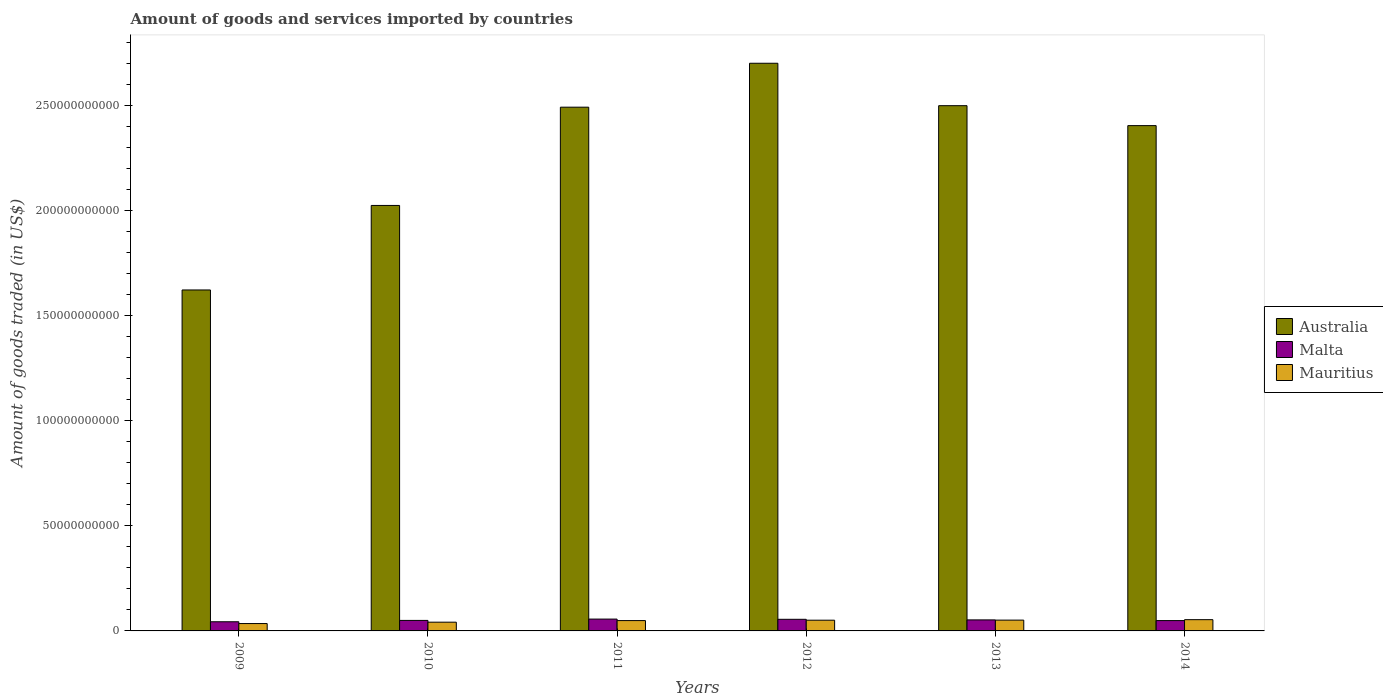How many groups of bars are there?
Make the answer very short. 6. Are the number of bars per tick equal to the number of legend labels?
Give a very brief answer. Yes. Are the number of bars on each tick of the X-axis equal?
Provide a succinct answer. Yes. How many bars are there on the 2nd tick from the left?
Ensure brevity in your answer.  3. What is the label of the 3rd group of bars from the left?
Provide a succinct answer. 2011. What is the total amount of goods and services imported in Malta in 2013?
Ensure brevity in your answer.  5.25e+09. Across all years, what is the maximum total amount of goods and services imported in Malta?
Provide a succinct answer. 5.64e+09. Across all years, what is the minimum total amount of goods and services imported in Mauritius?
Ensure brevity in your answer.  3.50e+09. In which year was the total amount of goods and services imported in Malta maximum?
Give a very brief answer. 2011. What is the total total amount of goods and services imported in Australia in the graph?
Ensure brevity in your answer.  1.37e+12. What is the difference between the total amount of goods and services imported in Mauritius in 2009 and that in 2013?
Offer a very short reply. -1.64e+09. What is the difference between the total amount of goods and services imported in Australia in 2011 and the total amount of goods and services imported in Malta in 2009?
Give a very brief answer. 2.45e+11. What is the average total amount of goods and services imported in Malta per year?
Your response must be concise. 5.12e+09. In the year 2014, what is the difference between the total amount of goods and services imported in Mauritius and total amount of goods and services imported in Malta?
Make the answer very short. 4.33e+08. In how many years, is the total amount of goods and services imported in Australia greater than 80000000000 US$?
Your response must be concise. 6. What is the ratio of the total amount of goods and services imported in Mauritius in 2009 to that in 2014?
Ensure brevity in your answer.  0.65. What is the difference between the highest and the second highest total amount of goods and services imported in Australia?
Keep it short and to the point. 2.02e+1. What is the difference between the highest and the lowest total amount of goods and services imported in Australia?
Give a very brief answer. 1.08e+11. In how many years, is the total amount of goods and services imported in Australia greater than the average total amount of goods and services imported in Australia taken over all years?
Offer a very short reply. 4. What does the 1st bar from the left in 2014 represents?
Your answer should be very brief. Australia. What does the 1st bar from the right in 2009 represents?
Your response must be concise. Mauritius. Is it the case that in every year, the sum of the total amount of goods and services imported in Malta and total amount of goods and services imported in Mauritius is greater than the total amount of goods and services imported in Australia?
Give a very brief answer. No. What is the difference between two consecutive major ticks on the Y-axis?
Your response must be concise. 5.00e+1. Does the graph contain grids?
Make the answer very short. No. Where does the legend appear in the graph?
Give a very brief answer. Center right. How many legend labels are there?
Your answer should be compact. 3. What is the title of the graph?
Offer a terse response. Amount of goods and services imported by countries. What is the label or title of the Y-axis?
Offer a terse response. Amount of goods traded (in US$). What is the Amount of goods traded (in US$) in Australia in 2009?
Keep it short and to the point. 1.62e+11. What is the Amount of goods traded (in US$) of Malta in 2009?
Provide a succinct answer. 4.36e+09. What is the Amount of goods traded (in US$) in Mauritius in 2009?
Provide a short and direct response. 3.50e+09. What is the Amount of goods traded (in US$) in Australia in 2010?
Ensure brevity in your answer.  2.02e+11. What is the Amount of goods traded (in US$) in Malta in 2010?
Offer a very short reply. 5.00e+09. What is the Amount of goods traded (in US$) in Mauritius in 2010?
Offer a very short reply. 4.16e+09. What is the Amount of goods traded (in US$) of Australia in 2011?
Your response must be concise. 2.49e+11. What is the Amount of goods traded (in US$) of Malta in 2011?
Provide a succinct answer. 5.64e+09. What is the Amount of goods traded (in US$) in Mauritius in 2011?
Offer a very short reply. 4.92e+09. What is the Amount of goods traded (in US$) in Australia in 2012?
Ensure brevity in your answer.  2.70e+11. What is the Amount of goods traded (in US$) of Malta in 2012?
Give a very brief answer. 5.53e+09. What is the Amount of goods traded (in US$) in Mauritius in 2012?
Make the answer very short. 5.10e+09. What is the Amount of goods traded (in US$) in Australia in 2013?
Keep it short and to the point. 2.50e+11. What is the Amount of goods traded (in US$) in Malta in 2013?
Your answer should be compact. 5.25e+09. What is the Amount of goods traded (in US$) of Mauritius in 2013?
Provide a succinct answer. 5.14e+09. What is the Amount of goods traded (in US$) of Australia in 2014?
Provide a short and direct response. 2.40e+11. What is the Amount of goods traded (in US$) of Malta in 2014?
Your response must be concise. 4.92e+09. What is the Amount of goods traded (in US$) of Mauritius in 2014?
Ensure brevity in your answer.  5.35e+09. Across all years, what is the maximum Amount of goods traded (in US$) of Australia?
Your answer should be very brief. 2.70e+11. Across all years, what is the maximum Amount of goods traded (in US$) in Malta?
Provide a succinct answer. 5.64e+09. Across all years, what is the maximum Amount of goods traded (in US$) in Mauritius?
Provide a short and direct response. 5.35e+09. Across all years, what is the minimum Amount of goods traded (in US$) in Australia?
Your answer should be very brief. 1.62e+11. Across all years, what is the minimum Amount of goods traded (in US$) of Malta?
Provide a succinct answer. 4.36e+09. Across all years, what is the minimum Amount of goods traded (in US$) in Mauritius?
Keep it short and to the point. 3.50e+09. What is the total Amount of goods traded (in US$) in Australia in the graph?
Ensure brevity in your answer.  1.37e+12. What is the total Amount of goods traded (in US$) in Malta in the graph?
Make the answer very short. 3.07e+1. What is the total Amount of goods traded (in US$) of Mauritius in the graph?
Give a very brief answer. 2.82e+1. What is the difference between the Amount of goods traded (in US$) of Australia in 2009 and that in 2010?
Provide a short and direct response. -4.02e+1. What is the difference between the Amount of goods traded (in US$) of Malta in 2009 and that in 2010?
Make the answer very short. -6.45e+08. What is the difference between the Amount of goods traded (in US$) in Mauritius in 2009 and that in 2010?
Your answer should be compact. -6.53e+08. What is the difference between the Amount of goods traded (in US$) in Australia in 2009 and that in 2011?
Keep it short and to the point. -8.70e+1. What is the difference between the Amount of goods traded (in US$) of Malta in 2009 and that in 2011?
Offer a terse response. -1.28e+09. What is the difference between the Amount of goods traded (in US$) of Mauritius in 2009 and that in 2011?
Keep it short and to the point. -1.41e+09. What is the difference between the Amount of goods traded (in US$) in Australia in 2009 and that in 2012?
Give a very brief answer. -1.08e+11. What is the difference between the Amount of goods traded (in US$) of Malta in 2009 and that in 2012?
Ensure brevity in your answer.  -1.17e+09. What is the difference between the Amount of goods traded (in US$) in Mauritius in 2009 and that in 2012?
Give a very brief answer. -1.60e+09. What is the difference between the Amount of goods traded (in US$) in Australia in 2009 and that in 2013?
Make the answer very short. -8.77e+1. What is the difference between the Amount of goods traded (in US$) in Malta in 2009 and that in 2013?
Your response must be concise. -8.90e+08. What is the difference between the Amount of goods traded (in US$) of Mauritius in 2009 and that in 2013?
Provide a short and direct response. -1.64e+09. What is the difference between the Amount of goods traded (in US$) of Australia in 2009 and that in 2014?
Your response must be concise. -7.82e+1. What is the difference between the Amount of goods traded (in US$) of Malta in 2009 and that in 2014?
Give a very brief answer. -5.63e+08. What is the difference between the Amount of goods traded (in US$) of Mauritius in 2009 and that in 2014?
Your answer should be compact. -1.85e+09. What is the difference between the Amount of goods traded (in US$) in Australia in 2010 and that in 2011?
Your answer should be very brief. -4.68e+1. What is the difference between the Amount of goods traded (in US$) of Malta in 2010 and that in 2011?
Make the answer very short. -6.33e+08. What is the difference between the Amount of goods traded (in US$) in Mauritius in 2010 and that in 2011?
Ensure brevity in your answer.  -7.61e+08. What is the difference between the Amount of goods traded (in US$) in Australia in 2010 and that in 2012?
Your response must be concise. -6.77e+1. What is the difference between the Amount of goods traded (in US$) in Malta in 2010 and that in 2012?
Provide a short and direct response. -5.25e+08. What is the difference between the Amount of goods traded (in US$) in Mauritius in 2010 and that in 2012?
Offer a very short reply. -9.48e+08. What is the difference between the Amount of goods traded (in US$) of Australia in 2010 and that in 2013?
Your response must be concise. -4.75e+1. What is the difference between the Amount of goods traded (in US$) of Malta in 2010 and that in 2013?
Keep it short and to the point. -2.46e+08. What is the difference between the Amount of goods traded (in US$) of Mauritius in 2010 and that in 2013?
Your answer should be very brief. -9.82e+08. What is the difference between the Amount of goods traded (in US$) of Australia in 2010 and that in 2014?
Offer a terse response. -3.80e+1. What is the difference between the Amount of goods traded (in US$) of Malta in 2010 and that in 2014?
Make the answer very short. 8.20e+07. What is the difference between the Amount of goods traded (in US$) of Mauritius in 2010 and that in 2014?
Keep it short and to the point. -1.20e+09. What is the difference between the Amount of goods traded (in US$) in Australia in 2011 and that in 2012?
Provide a short and direct response. -2.09e+1. What is the difference between the Amount of goods traded (in US$) of Malta in 2011 and that in 2012?
Give a very brief answer. 1.08e+08. What is the difference between the Amount of goods traded (in US$) in Mauritius in 2011 and that in 2012?
Your answer should be very brief. -1.87e+08. What is the difference between the Amount of goods traded (in US$) in Australia in 2011 and that in 2013?
Offer a very short reply. -7.10e+08. What is the difference between the Amount of goods traded (in US$) in Malta in 2011 and that in 2013?
Offer a very short reply. 3.87e+08. What is the difference between the Amount of goods traded (in US$) of Mauritius in 2011 and that in 2013?
Provide a succinct answer. -2.22e+08. What is the difference between the Amount of goods traded (in US$) of Australia in 2011 and that in 2014?
Provide a short and direct response. 8.77e+09. What is the difference between the Amount of goods traded (in US$) of Malta in 2011 and that in 2014?
Give a very brief answer. 7.15e+08. What is the difference between the Amount of goods traded (in US$) in Mauritius in 2011 and that in 2014?
Offer a terse response. -4.36e+08. What is the difference between the Amount of goods traded (in US$) of Australia in 2012 and that in 2013?
Ensure brevity in your answer.  2.02e+1. What is the difference between the Amount of goods traded (in US$) of Malta in 2012 and that in 2013?
Make the answer very short. 2.79e+08. What is the difference between the Amount of goods traded (in US$) of Mauritius in 2012 and that in 2013?
Offer a terse response. -3.42e+07. What is the difference between the Amount of goods traded (in US$) of Australia in 2012 and that in 2014?
Your answer should be very brief. 2.97e+1. What is the difference between the Amount of goods traded (in US$) in Malta in 2012 and that in 2014?
Provide a succinct answer. 6.07e+08. What is the difference between the Amount of goods traded (in US$) in Mauritius in 2012 and that in 2014?
Give a very brief answer. -2.49e+08. What is the difference between the Amount of goods traded (in US$) in Australia in 2013 and that in 2014?
Your answer should be very brief. 9.48e+09. What is the difference between the Amount of goods traded (in US$) in Malta in 2013 and that in 2014?
Ensure brevity in your answer.  3.28e+08. What is the difference between the Amount of goods traded (in US$) of Mauritius in 2013 and that in 2014?
Ensure brevity in your answer.  -2.14e+08. What is the difference between the Amount of goods traded (in US$) in Australia in 2009 and the Amount of goods traded (in US$) in Malta in 2010?
Ensure brevity in your answer.  1.57e+11. What is the difference between the Amount of goods traded (in US$) of Australia in 2009 and the Amount of goods traded (in US$) of Mauritius in 2010?
Keep it short and to the point. 1.58e+11. What is the difference between the Amount of goods traded (in US$) in Malta in 2009 and the Amount of goods traded (in US$) in Mauritius in 2010?
Provide a succinct answer. 2.01e+08. What is the difference between the Amount of goods traded (in US$) of Australia in 2009 and the Amount of goods traded (in US$) of Malta in 2011?
Ensure brevity in your answer.  1.57e+11. What is the difference between the Amount of goods traded (in US$) of Australia in 2009 and the Amount of goods traded (in US$) of Mauritius in 2011?
Your answer should be compact. 1.57e+11. What is the difference between the Amount of goods traded (in US$) of Malta in 2009 and the Amount of goods traded (in US$) of Mauritius in 2011?
Your answer should be very brief. -5.60e+08. What is the difference between the Amount of goods traded (in US$) in Australia in 2009 and the Amount of goods traded (in US$) in Malta in 2012?
Your response must be concise. 1.57e+11. What is the difference between the Amount of goods traded (in US$) of Australia in 2009 and the Amount of goods traded (in US$) of Mauritius in 2012?
Give a very brief answer. 1.57e+11. What is the difference between the Amount of goods traded (in US$) of Malta in 2009 and the Amount of goods traded (in US$) of Mauritius in 2012?
Provide a succinct answer. -7.47e+08. What is the difference between the Amount of goods traded (in US$) of Australia in 2009 and the Amount of goods traded (in US$) of Malta in 2013?
Your answer should be very brief. 1.57e+11. What is the difference between the Amount of goods traded (in US$) in Australia in 2009 and the Amount of goods traded (in US$) in Mauritius in 2013?
Your answer should be very brief. 1.57e+11. What is the difference between the Amount of goods traded (in US$) in Malta in 2009 and the Amount of goods traded (in US$) in Mauritius in 2013?
Offer a terse response. -7.81e+08. What is the difference between the Amount of goods traded (in US$) of Australia in 2009 and the Amount of goods traded (in US$) of Malta in 2014?
Keep it short and to the point. 1.57e+11. What is the difference between the Amount of goods traded (in US$) of Australia in 2009 and the Amount of goods traded (in US$) of Mauritius in 2014?
Offer a terse response. 1.57e+11. What is the difference between the Amount of goods traded (in US$) in Malta in 2009 and the Amount of goods traded (in US$) in Mauritius in 2014?
Your response must be concise. -9.96e+08. What is the difference between the Amount of goods traded (in US$) in Australia in 2010 and the Amount of goods traded (in US$) in Malta in 2011?
Provide a short and direct response. 1.97e+11. What is the difference between the Amount of goods traded (in US$) in Australia in 2010 and the Amount of goods traded (in US$) in Mauritius in 2011?
Provide a succinct answer. 1.98e+11. What is the difference between the Amount of goods traded (in US$) in Malta in 2010 and the Amount of goods traded (in US$) in Mauritius in 2011?
Give a very brief answer. 8.51e+07. What is the difference between the Amount of goods traded (in US$) in Australia in 2010 and the Amount of goods traded (in US$) in Malta in 2012?
Provide a succinct answer. 1.97e+11. What is the difference between the Amount of goods traded (in US$) in Australia in 2010 and the Amount of goods traded (in US$) in Mauritius in 2012?
Provide a short and direct response. 1.97e+11. What is the difference between the Amount of goods traded (in US$) in Malta in 2010 and the Amount of goods traded (in US$) in Mauritius in 2012?
Offer a very short reply. -1.02e+08. What is the difference between the Amount of goods traded (in US$) in Australia in 2010 and the Amount of goods traded (in US$) in Malta in 2013?
Keep it short and to the point. 1.97e+11. What is the difference between the Amount of goods traded (in US$) of Australia in 2010 and the Amount of goods traded (in US$) of Mauritius in 2013?
Keep it short and to the point. 1.97e+11. What is the difference between the Amount of goods traded (in US$) of Malta in 2010 and the Amount of goods traded (in US$) of Mauritius in 2013?
Make the answer very short. -1.37e+08. What is the difference between the Amount of goods traded (in US$) in Australia in 2010 and the Amount of goods traded (in US$) in Malta in 2014?
Your answer should be very brief. 1.98e+11. What is the difference between the Amount of goods traded (in US$) in Australia in 2010 and the Amount of goods traded (in US$) in Mauritius in 2014?
Offer a very short reply. 1.97e+11. What is the difference between the Amount of goods traded (in US$) in Malta in 2010 and the Amount of goods traded (in US$) in Mauritius in 2014?
Provide a succinct answer. -3.51e+08. What is the difference between the Amount of goods traded (in US$) in Australia in 2011 and the Amount of goods traded (in US$) in Malta in 2012?
Your answer should be very brief. 2.44e+11. What is the difference between the Amount of goods traded (in US$) in Australia in 2011 and the Amount of goods traded (in US$) in Mauritius in 2012?
Provide a succinct answer. 2.44e+11. What is the difference between the Amount of goods traded (in US$) in Malta in 2011 and the Amount of goods traded (in US$) in Mauritius in 2012?
Keep it short and to the point. 5.31e+08. What is the difference between the Amount of goods traded (in US$) in Australia in 2011 and the Amount of goods traded (in US$) in Malta in 2013?
Keep it short and to the point. 2.44e+11. What is the difference between the Amount of goods traded (in US$) of Australia in 2011 and the Amount of goods traded (in US$) of Mauritius in 2013?
Your answer should be very brief. 2.44e+11. What is the difference between the Amount of goods traded (in US$) of Malta in 2011 and the Amount of goods traded (in US$) of Mauritius in 2013?
Your answer should be compact. 4.96e+08. What is the difference between the Amount of goods traded (in US$) in Australia in 2011 and the Amount of goods traded (in US$) in Malta in 2014?
Your response must be concise. 2.44e+11. What is the difference between the Amount of goods traded (in US$) of Australia in 2011 and the Amount of goods traded (in US$) of Mauritius in 2014?
Your response must be concise. 2.44e+11. What is the difference between the Amount of goods traded (in US$) in Malta in 2011 and the Amount of goods traded (in US$) in Mauritius in 2014?
Your response must be concise. 2.82e+08. What is the difference between the Amount of goods traded (in US$) in Australia in 2012 and the Amount of goods traded (in US$) in Malta in 2013?
Your answer should be very brief. 2.65e+11. What is the difference between the Amount of goods traded (in US$) in Australia in 2012 and the Amount of goods traded (in US$) in Mauritius in 2013?
Keep it short and to the point. 2.65e+11. What is the difference between the Amount of goods traded (in US$) of Malta in 2012 and the Amount of goods traded (in US$) of Mauritius in 2013?
Offer a terse response. 3.88e+08. What is the difference between the Amount of goods traded (in US$) in Australia in 2012 and the Amount of goods traded (in US$) in Malta in 2014?
Offer a very short reply. 2.65e+11. What is the difference between the Amount of goods traded (in US$) in Australia in 2012 and the Amount of goods traded (in US$) in Mauritius in 2014?
Your answer should be very brief. 2.65e+11. What is the difference between the Amount of goods traded (in US$) in Malta in 2012 and the Amount of goods traded (in US$) in Mauritius in 2014?
Your response must be concise. 1.74e+08. What is the difference between the Amount of goods traded (in US$) of Australia in 2013 and the Amount of goods traded (in US$) of Malta in 2014?
Offer a terse response. 2.45e+11. What is the difference between the Amount of goods traded (in US$) in Australia in 2013 and the Amount of goods traded (in US$) in Mauritius in 2014?
Give a very brief answer. 2.45e+11. What is the difference between the Amount of goods traded (in US$) of Malta in 2013 and the Amount of goods traded (in US$) of Mauritius in 2014?
Ensure brevity in your answer.  -1.05e+08. What is the average Amount of goods traded (in US$) of Australia per year?
Your answer should be compact. 2.29e+11. What is the average Amount of goods traded (in US$) in Malta per year?
Provide a succinct answer. 5.12e+09. What is the average Amount of goods traded (in US$) in Mauritius per year?
Your response must be concise. 4.70e+09. In the year 2009, what is the difference between the Amount of goods traded (in US$) of Australia and Amount of goods traded (in US$) of Malta?
Your answer should be compact. 1.58e+11. In the year 2009, what is the difference between the Amount of goods traded (in US$) in Australia and Amount of goods traded (in US$) in Mauritius?
Ensure brevity in your answer.  1.59e+11. In the year 2009, what is the difference between the Amount of goods traded (in US$) in Malta and Amount of goods traded (in US$) in Mauritius?
Your answer should be very brief. 8.54e+08. In the year 2010, what is the difference between the Amount of goods traded (in US$) of Australia and Amount of goods traded (in US$) of Malta?
Provide a short and direct response. 1.97e+11. In the year 2010, what is the difference between the Amount of goods traded (in US$) in Australia and Amount of goods traded (in US$) in Mauritius?
Offer a terse response. 1.98e+11. In the year 2010, what is the difference between the Amount of goods traded (in US$) in Malta and Amount of goods traded (in US$) in Mauritius?
Offer a very short reply. 8.46e+08. In the year 2011, what is the difference between the Amount of goods traded (in US$) in Australia and Amount of goods traded (in US$) in Malta?
Offer a terse response. 2.44e+11. In the year 2011, what is the difference between the Amount of goods traded (in US$) in Australia and Amount of goods traded (in US$) in Mauritius?
Give a very brief answer. 2.44e+11. In the year 2011, what is the difference between the Amount of goods traded (in US$) of Malta and Amount of goods traded (in US$) of Mauritius?
Your answer should be very brief. 7.18e+08. In the year 2012, what is the difference between the Amount of goods traded (in US$) in Australia and Amount of goods traded (in US$) in Malta?
Keep it short and to the point. 2.65e+11. In the year 2012, what is the difference between the Amount of goods traded (in US$) in Australia and Amount of goods traded (in US$) in Mauritius?
Your answer should be compact. 2.65e+11. In the year 2012, what is the difference between the Amount of goods traded (in US$) of Malta and Amount of goods traded (in US$) of Mauritius?
Give a very brief answer. 4.23e+08. In the year 2013, what is the difference between the Amount of goods traded (in US$) of Australia and Amount of goods traded (in US$) of Malta?
Make the answer very short. 2.45e+11. In the year 2013, what is the difference between the Amount of goods traded (in US$) in Australia and Amount of goods traded (in US$) in Mauritius?
Keep it short and to the point. 2.45e+11. In the year 2013, what is the difference between the Amount of goods traded (in US$) of Malta and Amount of goods traded (in US$) of Mauritius?
Keep it short and to the point. 1.09e+08. In the year 2014, what is the difference between the Amount of goods traded (in US$) of Australia and Amount of goods traded (in US$) of Malta?
Provide a short and direct response. 2.36e+11. In the year 2014, what is the difference between the Amount of goods traded (in US$) in Australia and Amount of goods traded (in US$) in Mauritius?
Make the answer very short. 2.35e+11. In the year 2014, what is the difference between the Amount of goods traded (in US$) in Malta and Amount of goods traded (in US$) in Mauritius?
Your answer should be very brief. -4.33e+08. What is the ratio of the Amount of goods traded (in US$) in Australia in 2009 to that in 2010?
Ensure brevity in your answer.  0.8. What is the ratio of the Amount of goods traded (in US$) in Malta in 2009 to that in 2010?
Offer a terse response. 0.87. What is the ratio of the Amount of goods traded (in US$) in Mauritius in 2009 to that in 2010?
Make the answer very short. 0.84. What is the ratio of the Amount of goods traded (in US$) in Australia in 2009 to that in 2011?
Keep it short and to the point. 0.65. What is the ratio of the Amount of goods traded (in US$) in Malta in 2009 to that in 2011?
Offer a terse response. 0.77. What is the ratio of the Amount of goods traded (in US$) in Mauritius in 2009 to that in 2011?
Your response must be concise. 0.71. What is the ratio of the Amount of goods traded (in US$) of Australia in 2009 to that in 2012?
Your response must be concise. 0.6. What is the ratio of the Amount of goods traded (in US$) in Malta in 2009 to that in 2012?
Provide a succinct answer. 0.79. What is the ratio of the Amount of goods traded (in US$) of Mauritius in 2009 to that in 2012?
Your response must be concise. 0.69. What is the ratio of the Amount of goods traded (in US$) of Australia in 2009 to that in 2013?
Make the answer very short. 0.65. What is the ratio of the Amount of goods traded (in US$) of Malta in 2009 to that in 2013?
Keep it short and to the point. 0.83. What is the ratio of the Amount of goods traded (in US$) of Mauritius in 2009 to that in 2013?
Provide a succinct answer. 0.68. What is the ratio of the Amount of goods traded (in US$) of Australia in 2009 to that in 2014?
Give a very brief answer. 0.67. What is the ratio of the Amount of goods traded (in US$) of Malta in 2009 to that in 2014?
Your answer should be compact. 0.89. What is the ratio of the Amount of goods traded (in US$) of Mauritius in 2009 to that in 2014?
Your answer should be compact. 0.65. What is the ratio of the Amount of goods traded (in US$) of Australia in 2010 to that in 2011?
Offer a very short reply. 0.81. What is the ratio of the Amount of goods traded (in US$) in Malta in 2010 to that in 2011?
Your answer should be very brief. 0.89. What is the ratio of the Amount of goods traded (in US$) of Mauritius in 2010 to that in 2011?
Provide a succinct answer. 0.85. What is the ratio of the Amount of goods traded (in US$) in Australia in 2010 to that in 2012?
Provide a short and direct response. 0.75. What is the ratio of the Amount of goods traded (in US$) in Malta in 2010 to that in 2012?
Ensure brevity in your answer.  0.91. What is the ratio of the Amount of goods traded (in US$) in Mauritius in 2010 to that in 2012?
Give a very brief answer. 0.81. What is the ratio of the Amount of goods traded (in US$) of Australia in 2010 to that in 2013?
Provide a short and direct response. 0.81. What is the ratio of the Amount of goods traded (in US$) in Malta in 2010 to that in 2013?
Ensure brevity in your answer.  0.95. What is the ratio of the Amount of goods traded (in US$) in Mauritius in 2010 to that in 2013?
Provide a short and direct response. 0.81. What is the ratio of the Amount of goods traded (in US$) in Australia in 2010 to that in 2014?
Make the answer very short. 0.84. What is the ratio of the Amount of goods traded (in US$) in Malta in 2010 to that in 2014?
Offer a very short reply. 1.02. What is the ratio of the Amount of goods traded (in US$) of Mauritius in 2010 to that in 2014?
Make the answer very short. 0.78. What is the ratio of the Amount of goods traded (in US$) in Australia in 2011 to that in 2012?
Make the answer very short. 0.92. What is the ratio of the Amount of goods traded (in US$) in Malta in 2011 to that in 2012?
Offer a terse response. 1.02. What is the ratio of the Amount of goods traded (in US$) of Mauritius in 2011 to that in 2012?
Your answer should be compact. 0.96. What is the ratio of the Amount of goods traded (in US$) of Malta in 2011 to that in 2013?
Offer a terse response. 1.07. What is the ratio of the Amount of goods traded (in US$) in Mauritius in 2011 to that in 2013?
Offer a very short reply. 0.96. What is the ratio of the Amount of goods traded (in US$) of Australia in 2011 to that in 2014?
Offer a terse response. 1.04. What is the ratio of the Amount of goods traded (in US$) in Malta in 2011 to that in 2014?
Your answer should be very brief. 1.15. What is the ratio of the Amount of goods traded (in US$) of Mauritius in 2011 to that in 2014?
Provide a short and direct response. 0.92. What is the ratio of the Amount of goods traded (in US$) of Australia in 2012 to that in 2013?
Ensure brevity in your answer.  1.08. What is the ratio of the Amount of goods traded (in US$) in Malta in 2012 to that in 2013?
Keep it short and to the point. 1.05. What is the ratio of the Amount of goods traded (in US$) of Mauritius in 2012 to that in 2013?
Keep it short and to the point. 0.99. What is the ratio of the Amount of goods traded (in US$) in Australia in 2012 to that in 2014?
Your response must be concise. 1.12. What is the ratio of the Amount of goods traded (in US$) in Malta in 2012 to that in 2014?
Keep it short and to the point. 1.12. What is the ratio of the Amount of goods traded (in US$) of Mauritius in 2012 to that in 2014?
Offer a very short reply. 0.95. What is the ratio of the Amount of goods traded (in US$) of Australia in 2013 to that in 2014?
Provide a succinct answer. 1.04. What is the ratio of the Amount of goods traded (in US$) of Malta in 2013 to that in 2014?
Provide a short and direct response. 1.07. What is the ratio of the Amount of goods traded (in US$) of Mauritius in 2013 to that in 2014?
Ensure brevity in your answer.  0.96. What is the difference between the highest and the second highest Amount of goods traded (in US$) in Australia?
Offer a terse response. 2.02e+1. What is the difference between the highest and the second highest Amount of goods traded (in US$) of Malta?
Your response must be concise. 1.08e+08. What is the difference between the highest and the second highest Amount of goods traded (in US$) in Mauritius?
Give a very brief answer. 2.14e+08. What is the difference between the highest and the lowest Amount of goods traded (in US$) of Australia?
Ensure brevity in your answer.  1.08e+11. What is the difference between the highest and the lowest Amount of goods traded (in US$) of Malta?
Offer a very short reply. 1.28e+09. What is the difference between the highest and the lowest Amount of goods traded (in US$) in Mauritius?
Give a very brief answer. 1.85e+09. 